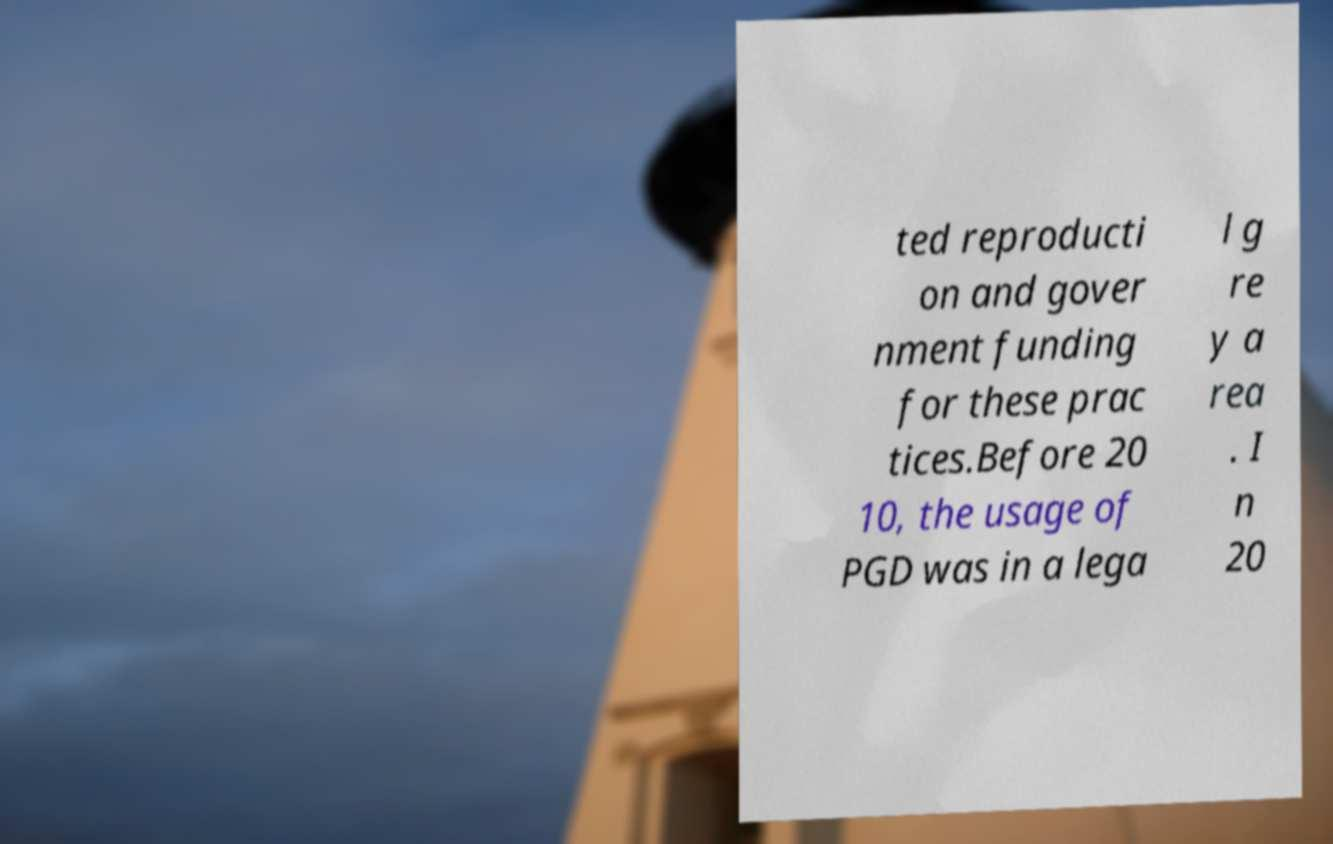What messages or text are displayed in this image? I need them in a readable, typed format. ted reproducti on and gover nment funding for these prac tices.Before 20 10, the usage of PGD was in a lega l g re y a rea . I n 20 